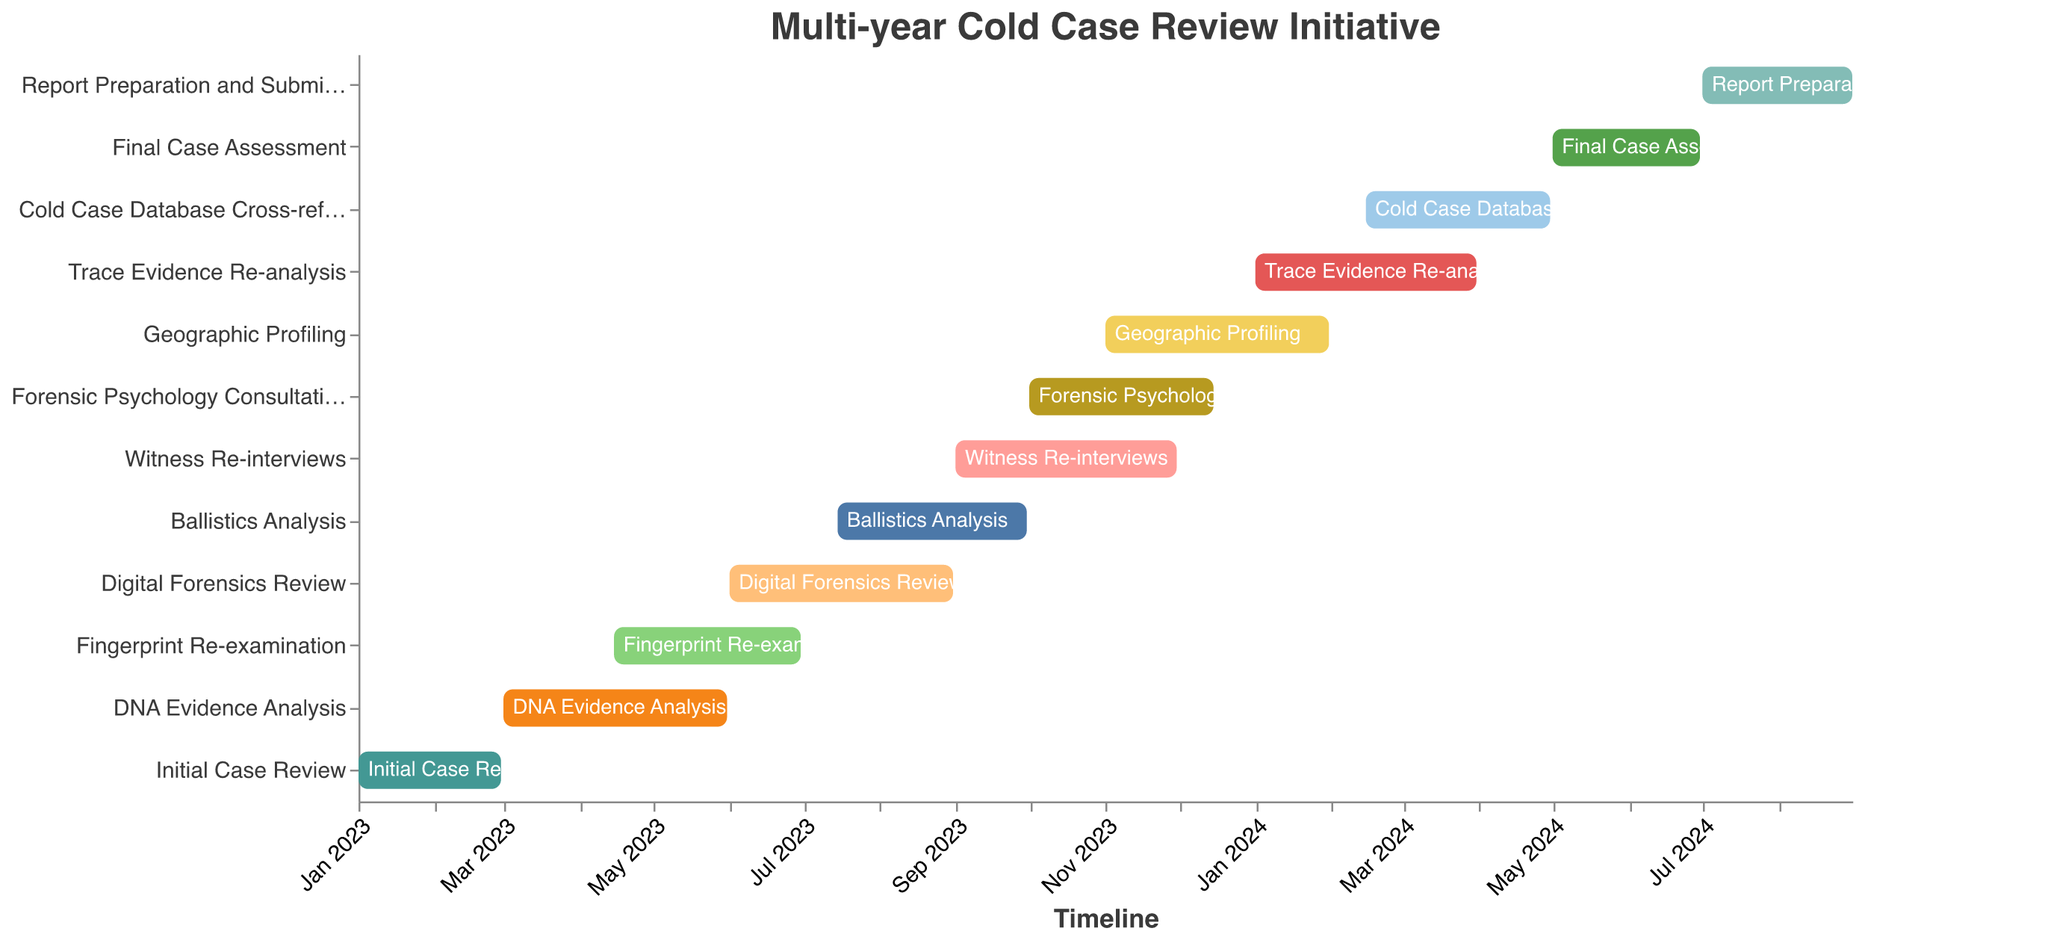What is the title of the Gantt Chart? The title of the Gantt Chart is displayed prominently at the top of the figure.
Answer: Multi-year Cold Case Review Initiative What task starts immediately after the "Initial Case Review"? The timeline axis shows that "Initial Case Review" ends on February 28, 2023, and the next task starting on March 1, 2023, is "DNA Evidence Analysis".
Answer: DNA Evidence Analysis Which task overlaps with the "Digital Forensics Review"? According to the timeline, "Digital Forensics Review" starts on June 1, 2023, and ends on August 31, 2023. The task that overlaps with this period is "Ballistics Analysis", which starts on July 15, 2023, and ends on September 30, 2023.
Answer: Ballistics Analysis How long does the "Trace Evidence Re-analysis" task last? "Trace Evidence Re-analysis" starts on January 1, 2024, and ends on March 31, 2024. Calculating the duration between these dates gives us three months.
Answer: 3 months What tasks are scheduled to end in June 2023? By looking at the timeline, we see that "Fingerprint Re-examination" and "Digital Forensics Review" are scheduled to end in June 2023.
Answer: Fingerprint Re-examination, Digital Forensics Review Which task has the longest duration? By checking the start and end dates of all tasks, we find that both "Geographic Profiling" and "Final Case Assessment" have the longest duration from November 1, 2023, to January 31, 2024, and from May 1, 2024, to June 30, 2024, respectively.
Answer: Geographic Profiling When does the "Forensic Psychology Consultation" take place? The Gantt Chart shows that "Forensic Psychology Consultation" takes place from October 1, 2023, to December 15, 2023.
Answer: October 1, 2023, to December 15, 2023 Which two tasks run concurrently from November 1, 2023? From November 1, 2023, both "Geographic Profiling" and "Witness Re-interviews" run concurrently.
Answer: Geographic Profiling, Witness Re-interviews When does the final task start and end? The final task, "Report Preparation and Submission," starts on July 1, 2024, and ends on August 31, 2024.
Answer: July 1, 2024, to August 31, 2024 